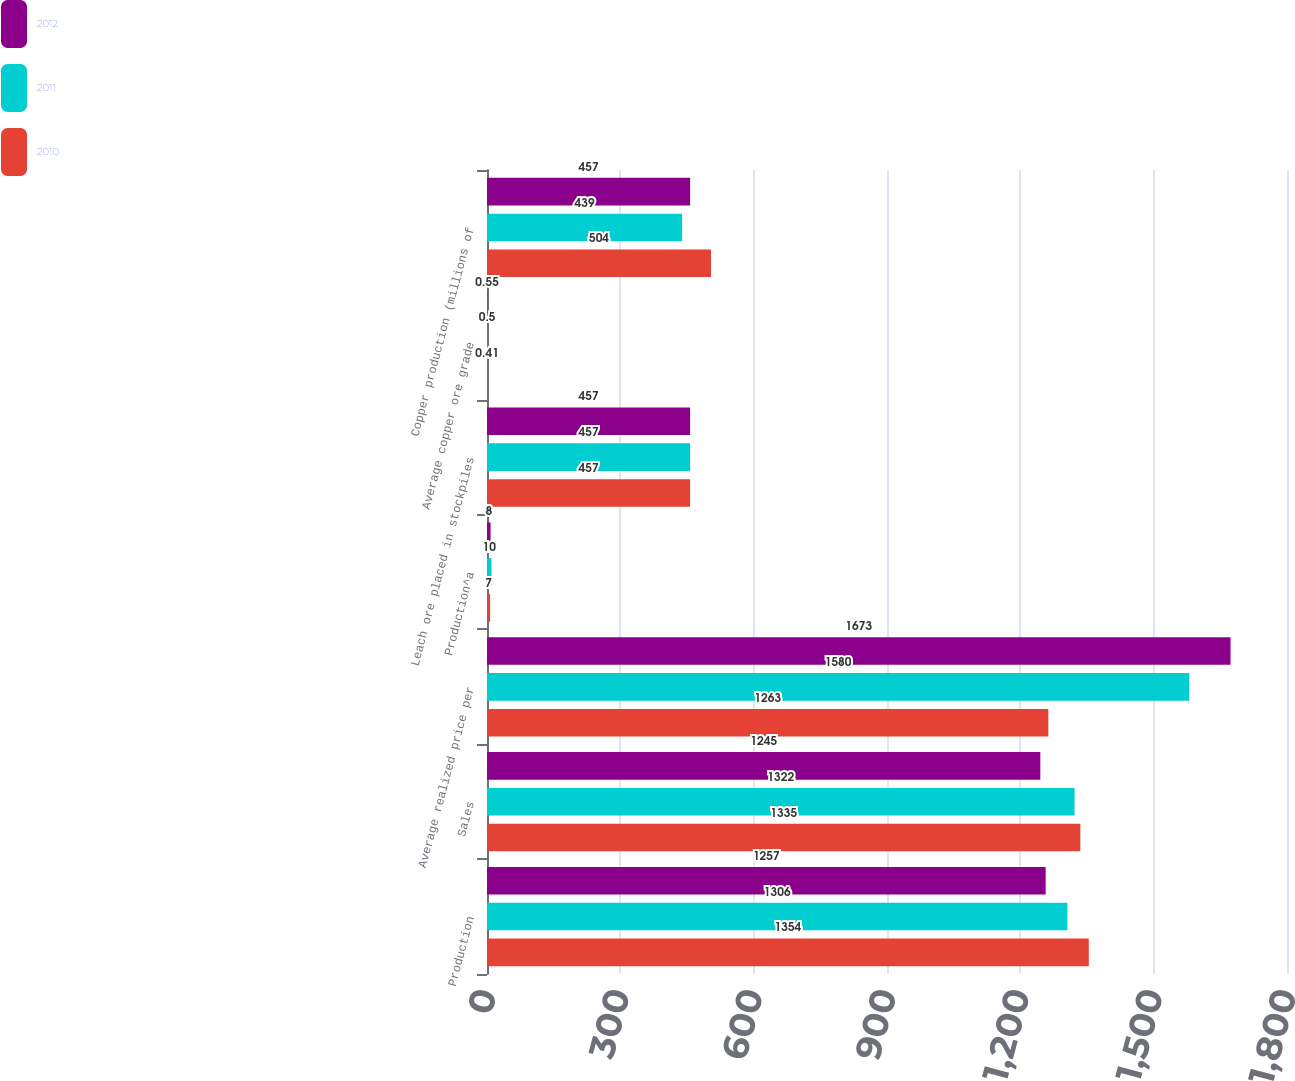<chart> <loc_0><loc_0><loc_500><loc_500><stacked_bar_chart><ecel><fcel>Production<fcel>Sales<fcel>Average realized price per<fcel>Production^a<fcel>Leach ore placed in stockpiles<fcel>Average copper ore grade<fcel>Copper production (millions of<nl><fcel>2012<fcel>1257<fcel>1245<fcel>1673<fcel>8<fcel>457<fcel>0.55<fcel>457<nl><fcel>2011<fcel>1306<fcel>1322<fcel>1580<fcel>10<fcel>457<fcel>0.5<fcel>439<nl><fcel>2010<fcel>1354<fcel>1335<fcel>1263<fcel>7<fcel>457<fcel>0.41<fcel>504<nl></chart> 